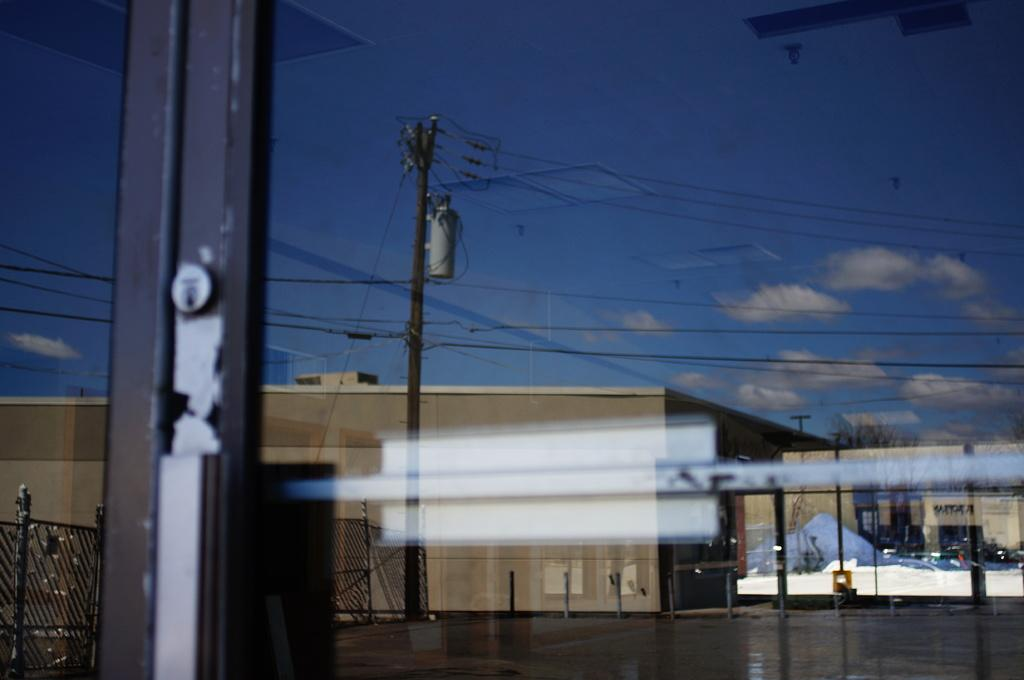What type of structures can be seen in the image? There are buildings in the image. What other objects are present in the image? There are poles, a fence, a tree, and wires visible in the image. What can be seen in the background of the image? The sky with clouds is visible in the background of the image. Can you see the face of the person blowing bubbles in the image? There is no person blowing bubbles present in the image. How many toes are visible on the tree in the image? Trees do not have toes, so this question cannot be answered based on the image. 